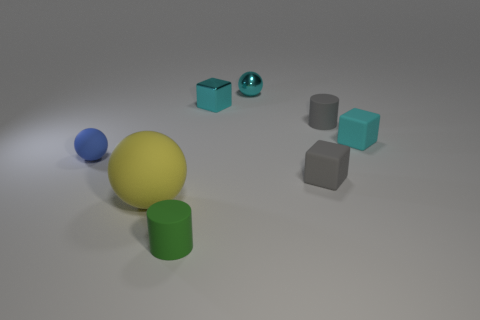How do the objects in the image relate to each other? The objects in the image are arranged in a way that may be representing a scale or progression of sizes and colors. The spheres, cubes, and cylinder appear to be deliberately placed to create a visual narrative or to illustrate concepts such as proportion, contrast, and hierarchy. The repetition of the cube form in different sizes and finishings suggests a thematic connection, emphasizing the study of geometry and texture. 